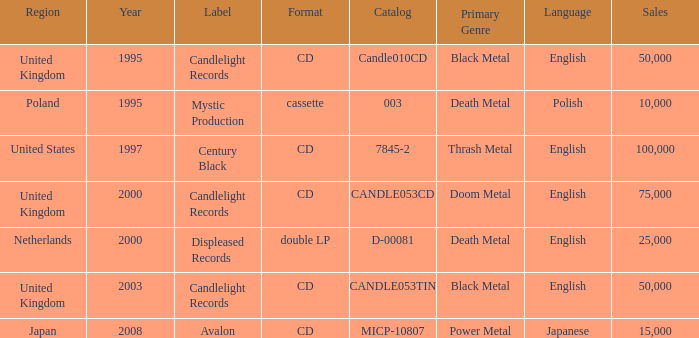Could you help me parse every detail presented in this table? {'header': ['Region', 'Year', 'Label', 'Format', 'Catalog', 'Primary Genre', 'Language', 'Sales'], 'rows': [['United Kingdom', '1995', 'Candlelight Records', 'CD', 'Candle010CD', 'Black Metal', 'English', '50,000'], ['Poland', '1995', 'Mystic Production', 'cassette', '003', 'Death Metal', 'Polish', '10,000'], ['United States', '1997', 'Century Black', 'CD', '7845-2', 'Thrash Metal', 'English', '100,000'], ['United Kingdom', '2000', 'Candlelight Records', 'CD', 'CANDLE053CD', 'Doom Metal', 'English', '75,000'], ['Netherlands', '2000', 'Displeased Records', 'double LP', 'D-00081', 'Death Metal', 'English', '25,000'], ['United Kingdom', '2003', 'Candlelight Records', 'CD', 'CANDLE053TIN', 'Black Metal', 'English', '50,000'], ['Japan', '2008', 'Avalon', 'CD', 'MICP-10807', 'Power Metal', 'Japanese', '15,000']]} What was the Candlelight Records Catalog of Candle053tin format? CD. 